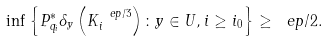<formula> <loc_0><loc_0><loc_500><loc_500>\inf \left \{ P _ { q _ { i } } ^ { * } \delta _ { y } \left ( K _ { i } ^ { \ e p / 3 } \right ) \colon y \in U , i \geq i _ { 0 } \right \} \geq \ e p / 2 .</formula> 